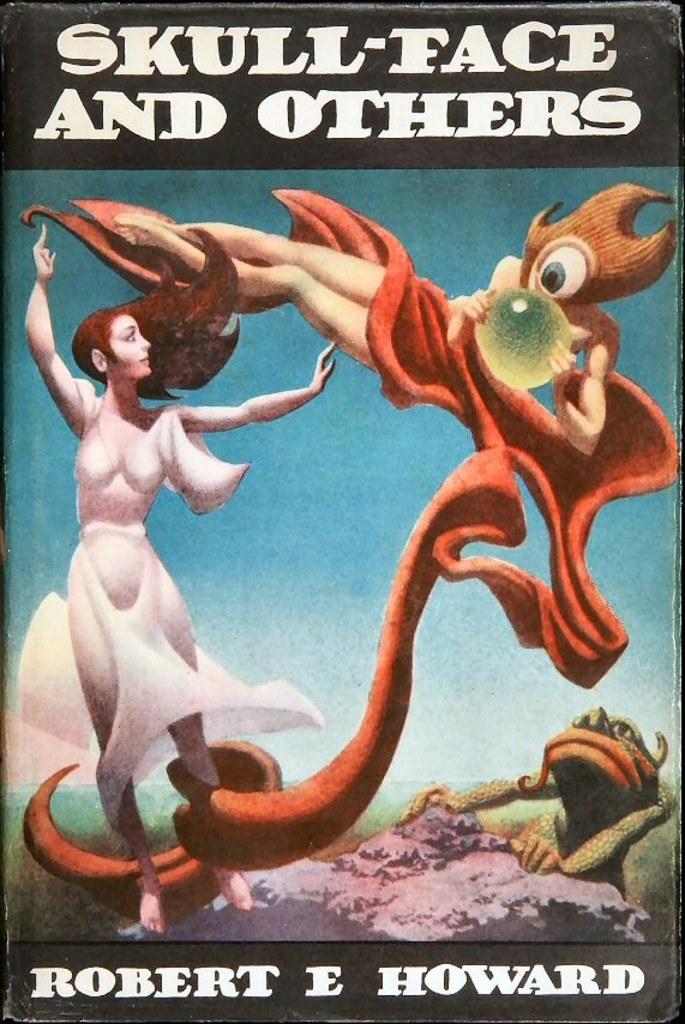What is the author's middle initial?
Provide a short and direct response. E. What is the title of the book?
Offer a very short reply. Skull-face and others. 